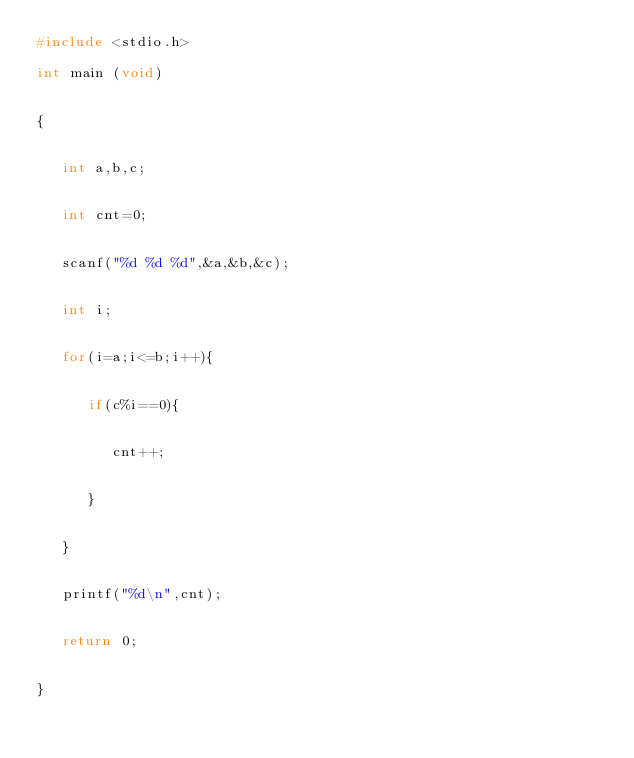Convert code to text. <code><loc_0><loc_0><loc_500><loc_500><_C_>#include <stdio.h>

int main (void)


{


   int a,b,c;


   int cnt=0;


   scanf("%d %d %d",&a,&b,&c);


   int i;


   for(i=a;i<=b;i++){


      if(c%i==0){


         cnt++;


      }


   }


   printf("%d\n",cnt);


   return 0;


}</code> 